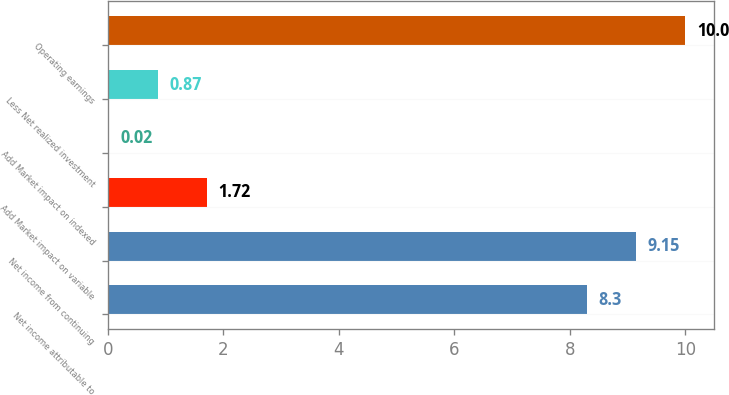<chart> <loc_0><loc_0><loc_500><loc_500><bar_chart><fcel>Net income attributable to<fcel>Net income from continuing<fcel>Add Market impact on variable<fcel>Add Market impact on indexed<fcel>Less Net realized investment<fcel>Operating earnings<nl><fcel>8.3<fcel>9.15<fcel>1.72<fcel>0.02<fcel>0.87<fcel>10<nl></chart> 